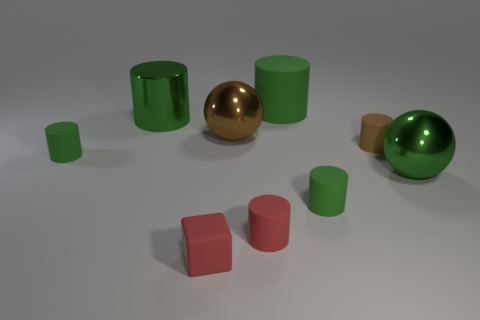Can you describe the material finish on the objects in the image? Certainly! The objects in the image exhibit a smooth and reflective finish. The spheres and cylinders have a consistent, shiny surface that indicates a metallic material, likely with a high-gloss paint finish to achieve such reflectiveness. 